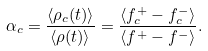<formula> <loc_0><loc_0><loc_500><loc_500>\alpha _ { c } = \frac { \langle \rho _ { c } ( t ) \rangle } { \langle \rho ( t ) \rangle } = \frac { \langle f ^ { + } _ { c } - f ^ { - } _ { c } \rangle } { \langle f ^ { + } - f ^ { - } \rangle } .</formula> 